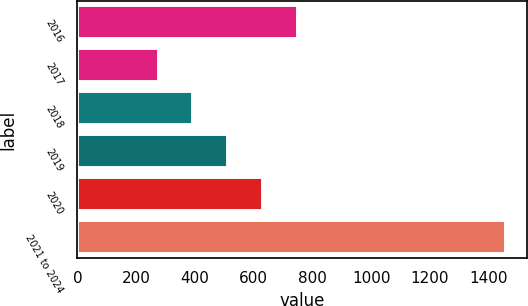Convert chart. <chart><loc_0><loc_0><loc_500><loc_500><bar_chart><fcel>2016<fcel>2017<fcel>2018<fcel>2019<fcel>2020<fcel>2021 to 2024<nl><fcel>749.2<fcel>276<fcel>394.3<fcel>512.6<fcel>630.9<fcel>1459<nl></chart> 